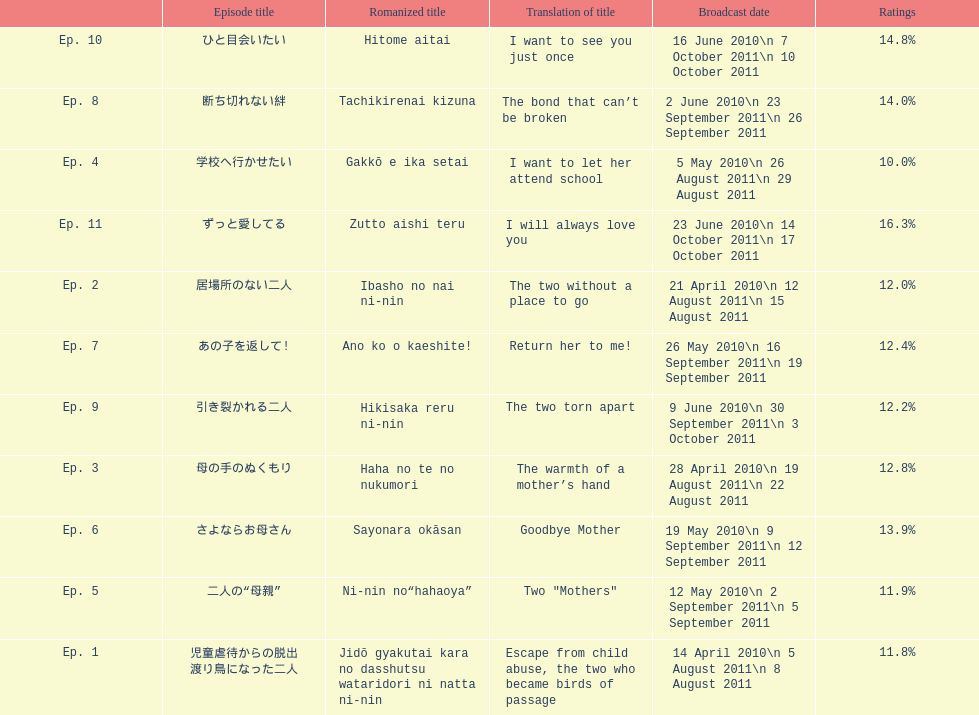What is the name of this series' premiere episode? 児童虐待からの脱出 渡り鳥になった二人. 